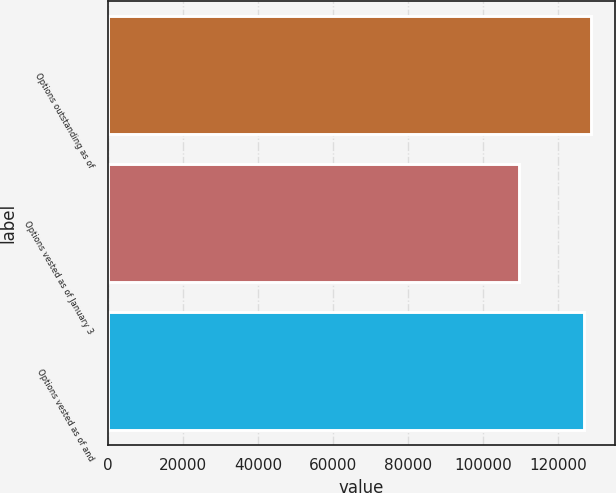<chart> <loc_0><loc_0><loc_500><loc_500><bar_chart><fcel>Options outstanding as of<fcel>Options vested as of January 3<fcel>Options vested as of and<nl><fcel>128605<fcel>109501<fcel>126866<nl></chart> 